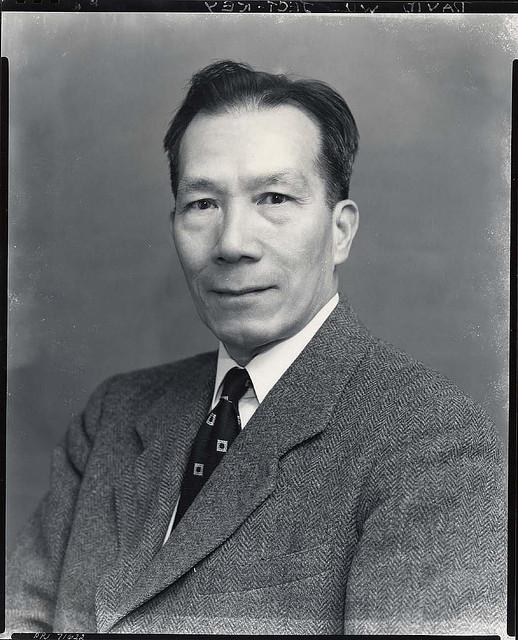Is the man Asian?
Keep it brief. Yes. How many stripes are on the man's necktie?
Keep it brief. 0. What style suit is this known as?
Answer briefly. Business. Are those lights on his tie?
Keep it brief. No. What type of clothing is this man wearing?
Keep it brief. Suit. Is this a man or a woman?
Write a very short answer. Man. Is he wearing a hat?
Keep it brief. No. Is that our president?
Concise answer only. No. Is this a woman or a man?
Short answer required. Man. 